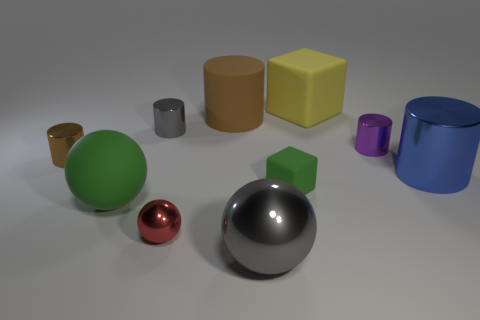Subtract all large brown cylinders. How many cylinders are left? 4 Subtract all red balls. How many balls are left? 2 Add 3 purple things. How many purple things are left? 4 Add 1 metallic balls. How many metallic balls exist? 3 Subtract 0 cyan cylinders. How many objects are left? 10 Subtract all cubes. How many objects are left? 8 Subtract 3 cylinders. How many cylinders are left? 2 Subtract all green cubes. Subtract all green balls. How many cubes are left? 1 Subtract all purple cubes. How many green balls are left? 1 Subtract all blue cylinders. Subtract all large blue metallic things. How many objects are left? 8 